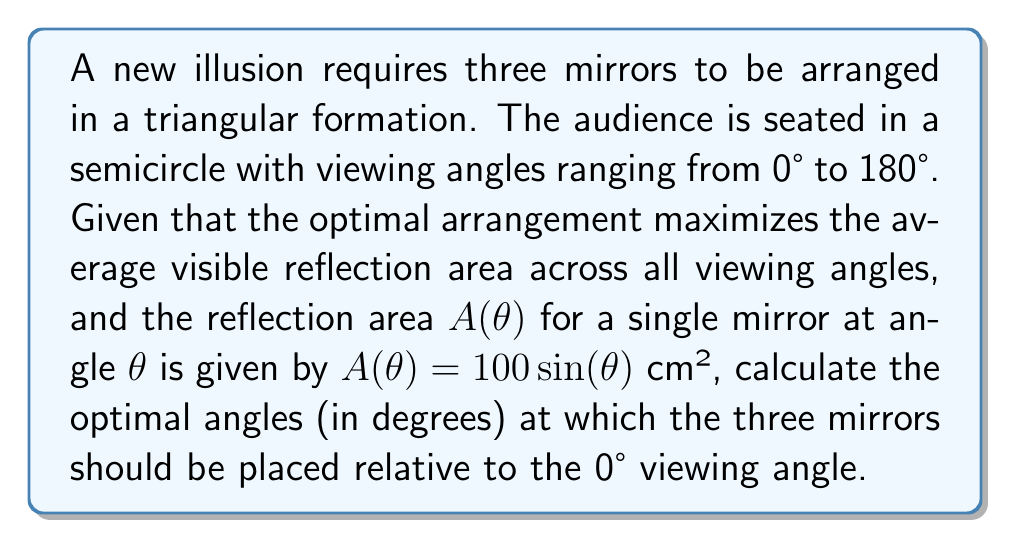Teach me how to tackle this problem. To solve this problem, we need to follow these steps:

1) The total visible reflection area $A_{total}(\theta_1, \theta_2, \theta_3)$ is the sum of the areas of the three mirrors:

   $$A_{total}(\theta_1, \theta_2, \theta_3) = 100[\sin(\theta_1) + \sin(\theta_2) + \sin(\theta_3)]$$

2) We want to maximize the average of this function over all viewing angles:

   $$\bar{A} = \frac{1}{\pi} \int_0^\pi A_{total}(\theta_1, \theta_2, \theta_3) d\theta$$

3) Substituting and simplifying:

   $$\bar{A} = \frac{100}{\pi} \int_0^\pi [\sin(\theta_1) + \sin(\theta_2) + \sin(\theta_3)] d\theta$$
   
   $$\bar{A} = \frac{100}{\pi} [\sin(\theta_1) + \sin(\theta_2) + \sin(\theta_3)] \int_0^\pi d\theta$$
   
   $$\bar{A} = 100[\sin(\theta_1) + \sin(\theta_2) + \sin(\theta_3)]$$

4) To maximize $\bar{A}$, we need to maximize $\sin(\theta_1) + \sin(\theta_2) + \sin(\theta_3)$.

5) Given the constraint that the mirrors form a triangle, we know $\theta_1 + \theta_2 + \theta_3 = 180°$.

6) The maximum value of $\sin(\theta_1) + \sin(\theta_2) + \sin(\theta_3)$ under this constraint occurs when $\theta_1 = \theta_2 = \theta_3 = 60°$.

Therefore, the optimal arrangement is to place the mirrors at 60°, 120°, and 180° relative to the 0° viewing angle.
Answer: 60°, 120°, 180° 